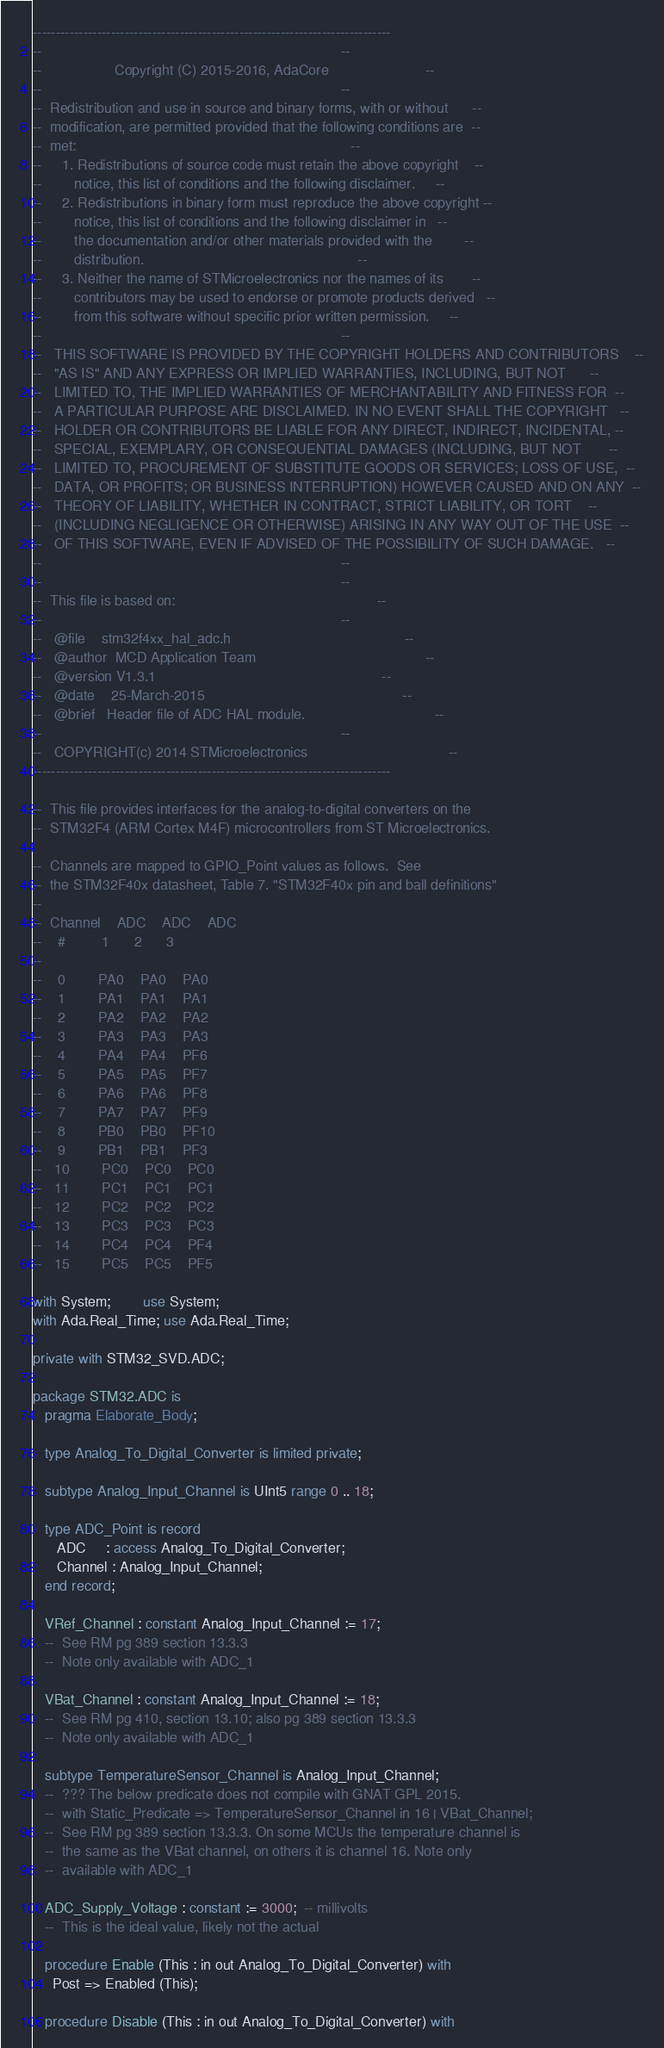Convert code to text. <code><loc_0><loc_0><loc_500><loc_500><_Ada_>------------------------------------------------------------------------------
--                                                                          --
--                  Copyright (C) 2015-2016, AdaCore                        --
--                                                                          --
--  Redistribution and use in source and binary forms, with or without      --
--  modification, are permitted provided that the following conditions are  --
--  met:                                                                    --
--     1. Redistributions of source code must retain the above copyright    --
--        notice, this list of conditions and the following disclaimer.     --
--     2. Redistributions in binary form must reproduce the above copyright --
--        notice, this list of conditions and the following disclaimer in   --
--        the documentation and/or other materials provided with the        --
--        distribution.                                                     --
--     3. Neither the name of STMicroelectronics nor the names of its       --
--        contributors may be used to endorse or promote products derived   --
--        from this software without specific prior written permission.     --
--                                                                          --
--   THIS SOFTWARE IS PROVIDED BY THE COPYRIGHT HOLDERS AND CONTRIBUTORS    --
--   "AS IS" AND ANY EXPRESS OR IMPLIED WARRANTIES, INCLUDING, BUT NOT      --
--   LIMITED TO, THE IMPLIED WARRANTIES OF MERCHANTABILITY AND FITNESS FOR  --
--   A PARTICULAR PURPOSE ARE DISCLAIMED. IN NO EVENT SHALL THE COPYRIGHT   --
--   HOLDER OR CONTRIBUTORS BE LIABLE FOR ANY DIRECT, INDIRECT, INCIDENTAL, --
--   SPECIAL, EXEMPLARY, OR CONSEQUENTIAL DAMAGES (INCLUDING, BUT NOT       --
--   LIMITED TO, PROCUREMENT OF SUBSTITUTE GOODS OR SERVICES; LOSS OF USE,  --
--   DATA, OR PROFITS; OR BUSINESS INTERRUPTION) HOWEVER CAUSED AND ON ANY  --
--   THEORY OF LIABILITY, WHETHER IN CONTRACT, STRICT LIABILITY, OR TORT    --
--   (INCLUDING NEGLIGENCE OR OTHERWISE) ARISING IN ANY WAY OUT OF THE USE  --
--   OF THIS SOFTWARE, EVEN IF ADVISED OF THE POSSIBILITY OF SUCH DAMAGE.   --
--                                                                          --
--                                                                          --
--  This file is based on:                                                  --
--                                                                          --
--   @file    stm32f4xx_hal_adc.h                                           --
--   @author  MCD Application Team                                          --
--   @version V1.3.1                                                        --
--   @date    25-March-2015                                                 --
--   @brief   Header file of ADC HAL module.                                --
--                                                                          --
--   COPYRIGHT(c) 2014 STMicroelectronics                                   --
------------------------------------------------------------------------------

--  This file provides interfaces for the analog-to-digital converters on the
--  STM32F4 (ARM Cortex M4F) microcontrollers from ST Microelectronics.

--  Channels are mapped to GPIO_Point values as follows.  See
--  the STM32F40x datasheet, Table 7. "STM32F40x pin and ball definitions"
--
--  Channel    ADC    ADC    ADC
--    #         1      2      3
--
--    0        PA0    PA0    PA0
--    1        PA1    PA1    PA1
--    2        PA2    PA2    PA2
--    3        PA3    PA3    PA3
--    4        PA4    PA4    PF6
--    5        PA5    PA5    PF7
--    6        PA6    PA6    PF8
--    7        PA7    PA7    PF9
--    8        PB0    PB0    PF10
--    9        PB1    PB1    PF3
--   10        PC0    PC0    PC0
--   11        PC1    PC1    PC1
--   12        PC2    PC2    PC2
--   13        PC3    PC3    PC3
--   14        PC4    PC4    PF4
--   15        PC5    PC5    PF5

with System;        use System;
with Ada.Real_Time; use Ada.Real_Time;

private with STM32_SVD.ADC;

package STM32.ADC is
   pragma Elaborate_Body;

   type Analog_To_Digital_Converter is limited private;

   subtype Analog_Input_Channel is UInt5 range 0 .. 18;

   type ADC_Point is record
      ADC     : access Analog_To_Digital_Converter;
      Channel : Analog_Input_Channel;
   end record;

   VRef_Channel : constant Analog_Input_Channel := 17;
   --  See RM pg 389 section 13.3.3
   --  Note only available with ADC_1

   VBat_Channel : constant Analog_Input_Channel := 18;
   --  See RM pg 410, section 13.10; also pg 389 section 13.3.3
   --  Note only available with ADC_1

   subtype TemperatureSensor_Channel is Analog_Input_Channel;
   --  ??? The below predicate does not compile with GNAT GPL 2015.
   --  with Static_Predicate => TemperatureSensor_Channel in 16 | VBat_Channel;
   --  See RM pg 389 section 13.3.3. On some MCUs the temperature channel is
   --  the same as the VBat channel, on others it is channel 16. Note only
   --  available with ADC_1

   ADC_Supply_Voltage : constant := 3000;  -- millivolts
   --  This is the ideal value, likely not the actual

   procedure Enable (This : in out Analog_To_Digital_Converter) with
     Post => Enabled (This);

   procedure Disable (This : in out Analog_To_Digital_Converter) with</code> 